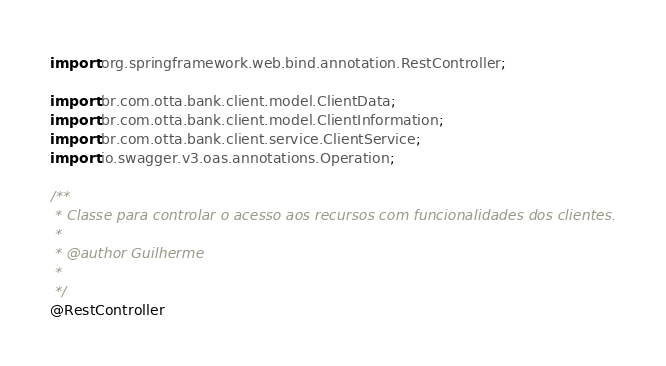Convert code to text. <code><loc_0><loc_0><loc_500><loc_500><_Java_>import org.springframework.web.bind.annotation.RestController;

import br.com.otta.bank.client.model.ClientData;
import br.com.otta.bank.client.model.ClientInformation;
import br.com.otta.bank.client.service.ClientService;
import io.swagger.v3.oas.annotations.Operation;

/**
 * Classe para controlar o acesso aos recursos com funcionalidades dos clientes.
 *
 * @author Guilherme
 *
 */
@RestController</code> 